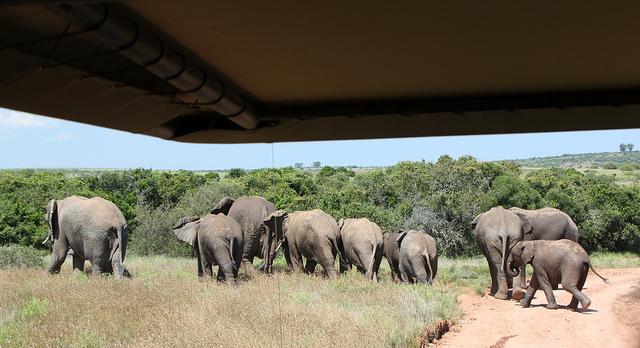Are these elephants in captivity?
Be succinct. No. How many elephants are pictured?
Write a very short answer. 9. Which elephant is the baby?
Be succinct. Far right. What animals are in the field?
Write a very short answer. Elephants. 